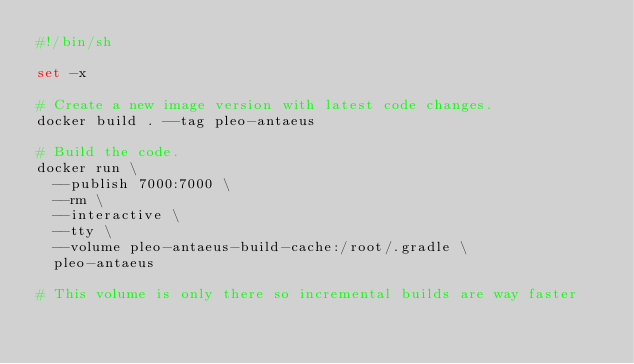<code> <loc_0><loc_0><loc_500><loc_500><_Bash_>#!/bin/sh

set -x

# Create a new image version with latest code changes.
docker build . --tag pleo-antaeus

# Build the code.
docker run \
  --publish 7000:7000 \
  --rm \
  --interactive \
  --tty \
  --volume pleo-antaeus-build-cache:/root/.gradle \
  pleo-antaeus

# This volume is only there so incremental builds are way faster
</code> 